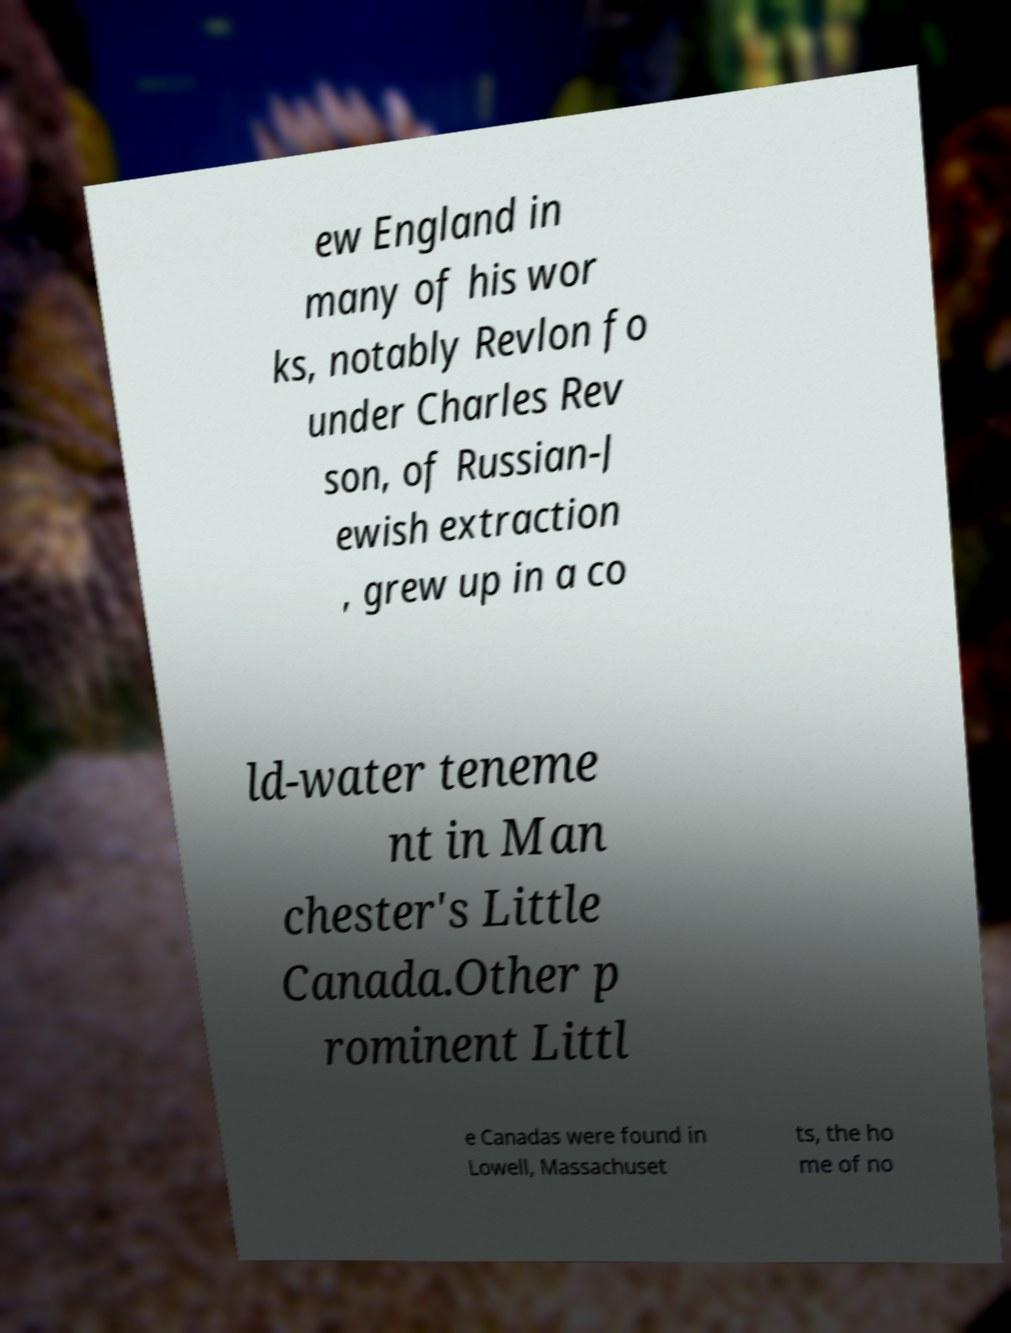For documentation purposes, I need the text within this image transcribed. Could you provide that? ew England in many of his wor ks, notably Revlon fo under Charles Rev son, of Russian-J ewish extraction , grew up in a co ld-water teneme nt in Man chester's Little Canada.Other p rominent Littl e Canadas were found in Lowell, Massachuset ts, the ho me of no 